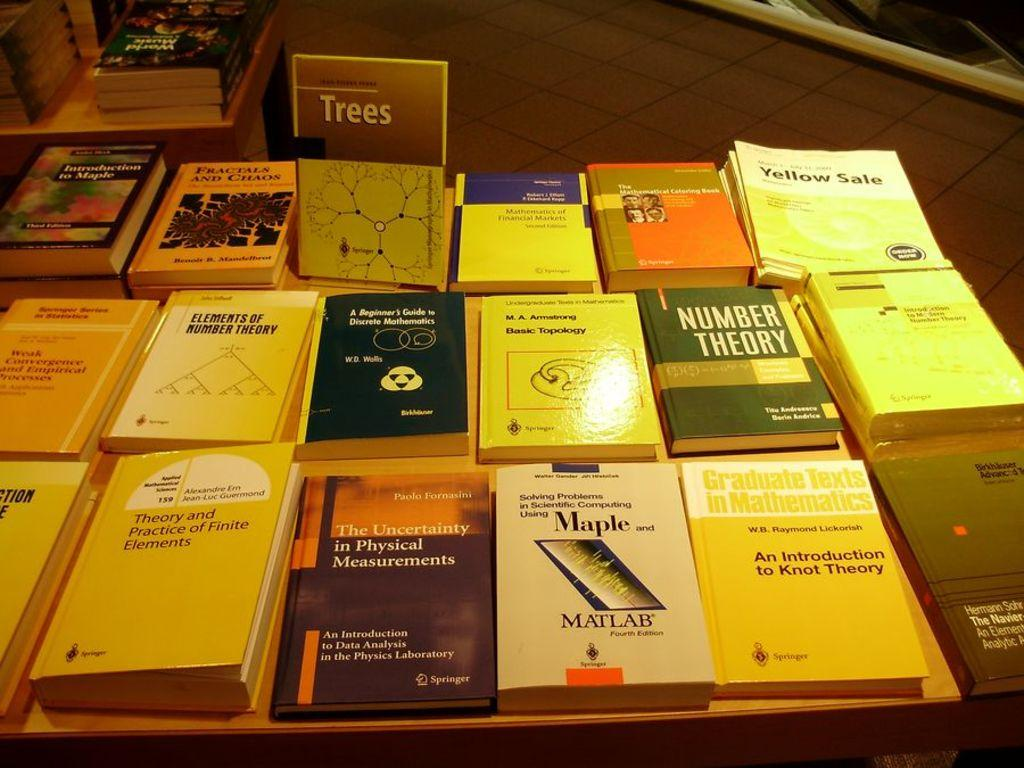<image>
Write a terse but informative summary of the picture. a table of books with one titled 'number theory' on it 